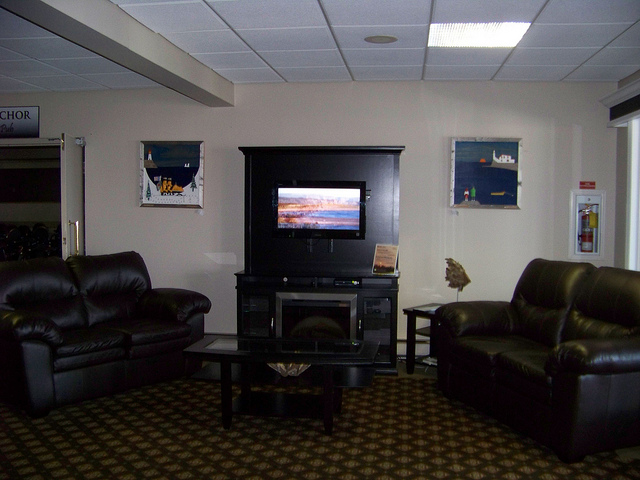Extract all visible text content from this image. CHOR 